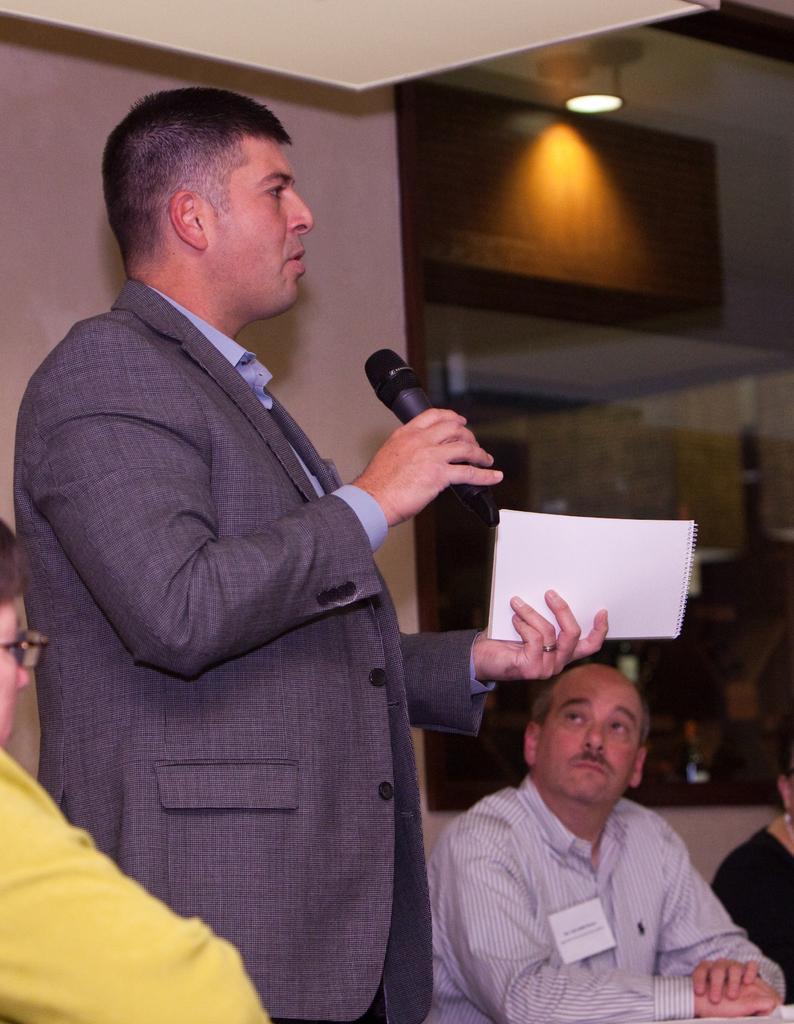What is the person in the image doing? The person is standing and talking on a microphone. What else is the person holding in the image? The person is holding a book in their hand. What can be observed about the people around the person? There are people sitting in chairs around the person. What type of horse can be seen in the image? There is no horse present in the image. What range of tools might a carpenter use in the image? There is no carpenter or tools present in the image. 